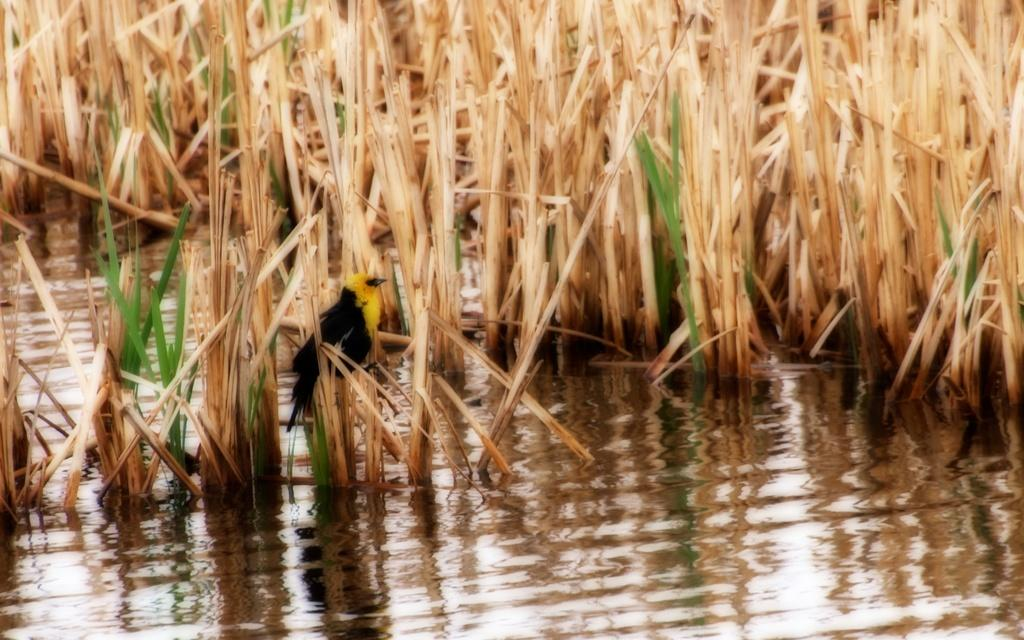What type of animal can be seen in the image? There is a bird in the image. Can you describe the bird's coloring? The bird has yellow and black coloring. What type of vegetation is visible in the image? There is grass visible in the image. How would you describe the grass's coloring? The grass has brown and green coloring. Is the grass in a specific environment in the image? Yes, the grass is partially in water. What type of government is depicted in the image? There is no depiction of a government in the image; it features a bird and grass. Can you tell me how many wrenches are visible in the image? There are no wrenches present in the image. 